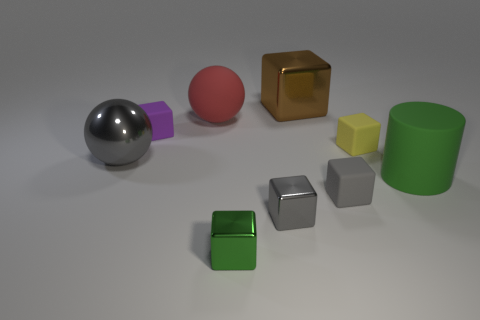There is a metal thing that is the same color as the metallic sphere; what size is it?
Provide a succinct answer. Small. Does the big ball that is behind the gray metallic ball have the same material as the small thing behind the yellow matte cube?
Offer a terse response. Yes. There is a sphere behind the gray metal ball; is it the same color as the matte cylinder?
Give a very brief answer. No. What number of small shiny blocks are on the left side of the small green cube?
Offer a very short reply. 0. Is the large red sphere made of the same material as the tiny yellow cube to the right of the brown metal block?
Offer a terse response. Yes. The red object that is the same material as the big cylinder is what size?
Offer a very short reply. Large. Are there more brown shiny objects that are on the right side of the large metal block than matte blocks in front of the yellow cube?
Give a very brief answer. No. Are there any other matte things of the same shape as the small green object?
Your answer should be compact. Yes. There is a gray cube that is right of the brown shiny block; does it have the same size as the rubber sphere?
Your answer should be compact. No. Is there a gray metal cylinder?
Your answer should be compact. No. 